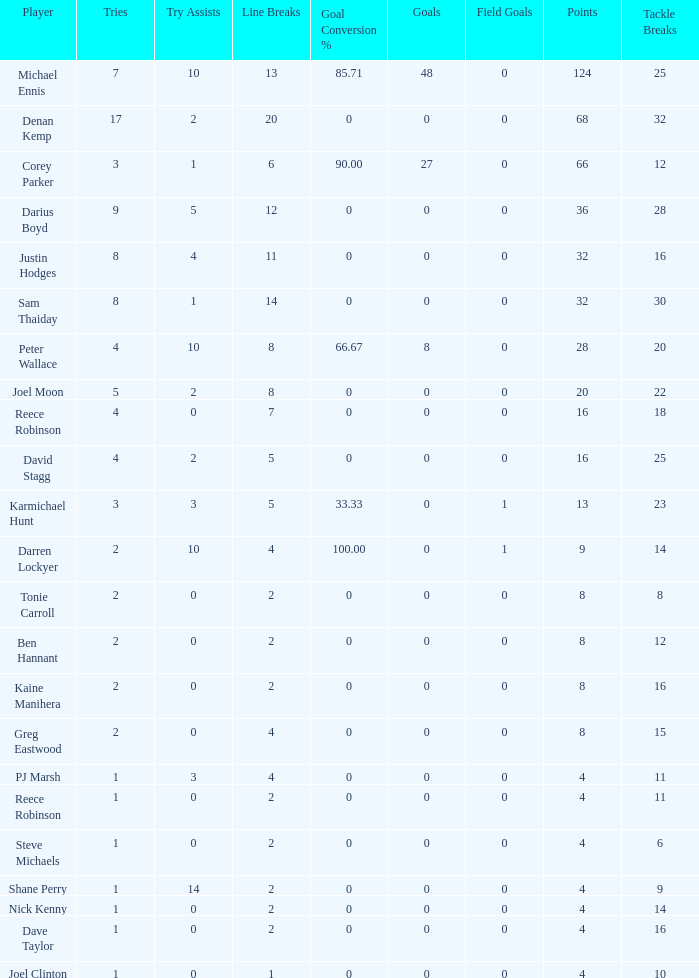What is the lowest tries the player with more than 0 goals, 28 points, and more than 0 field goals have? None. 